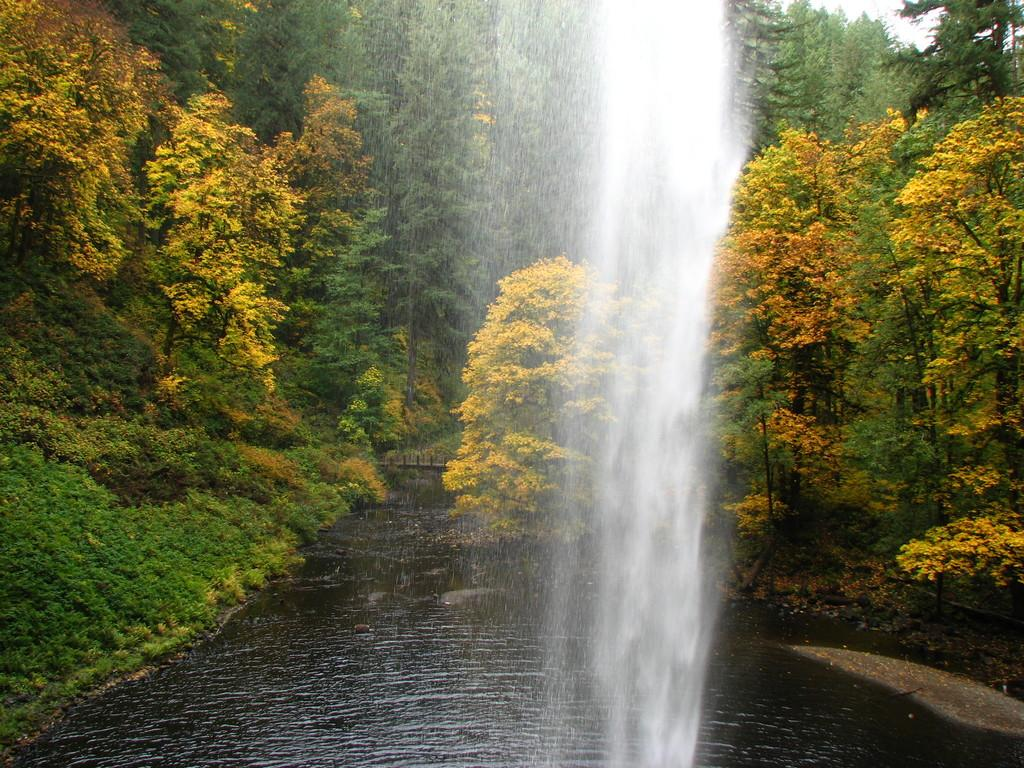What natural feature is the main subject of the image? There is a waterfall in the image. What type of vegetation can be seen in the background? There are many trees in the background of the image. What is present at the bottom of the image? There is water at the bottom of the image. What part of the sky is visible in the image? The sky is visible in the top right corner of the image. What type of news can be heard coming from the waterfall in the image? There is no indication in the image that any news is being broadcasted or heard from the waterfall. 